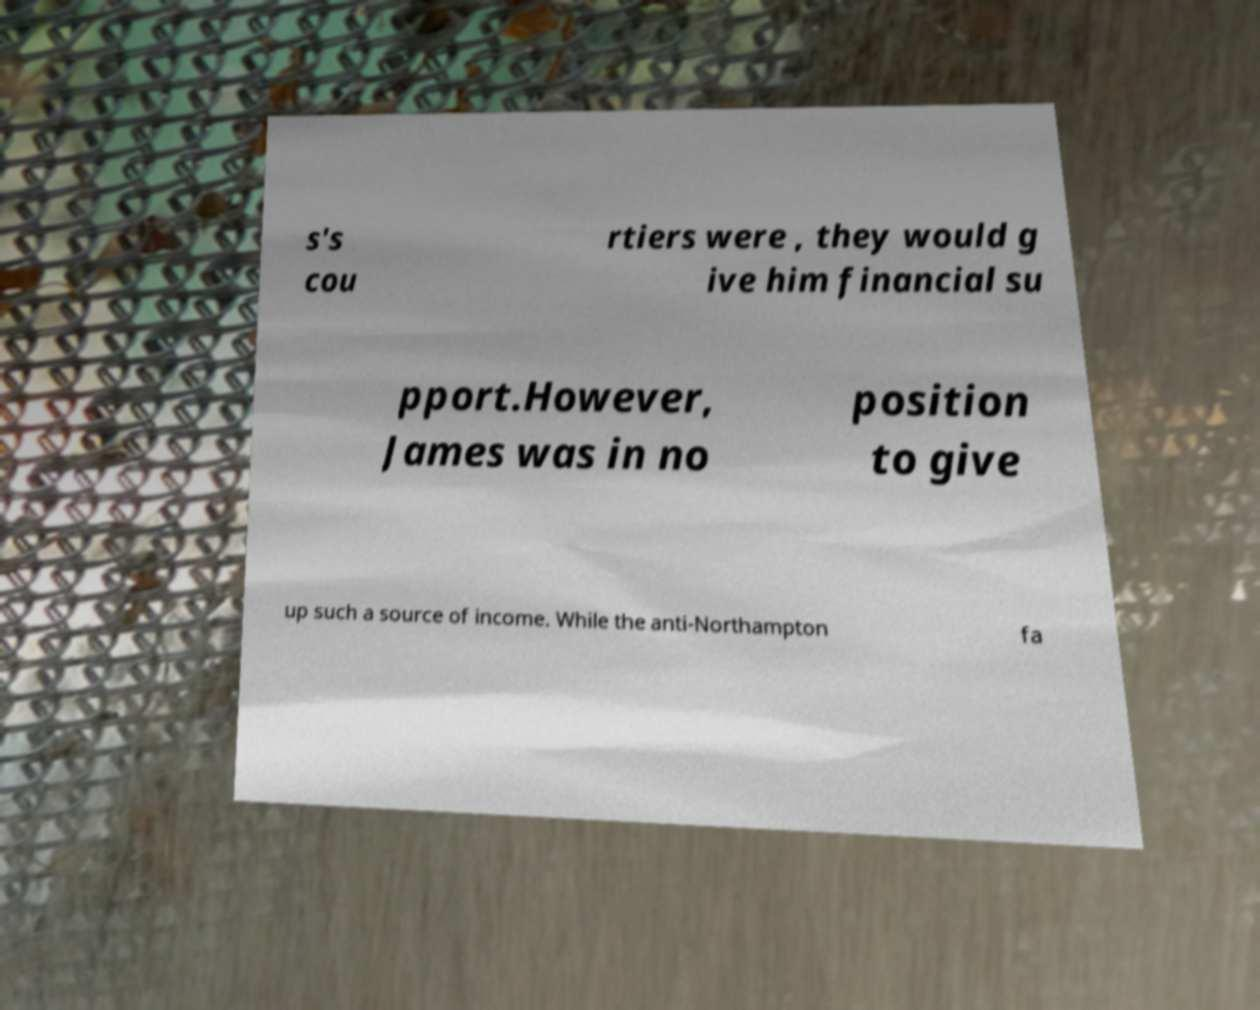Please identify and transcribe the text found in this image. s's cou rtiers were , they would g ive him financial su pport.However, James was in no position to give up such a source of income. While the anti-Northampton fa 